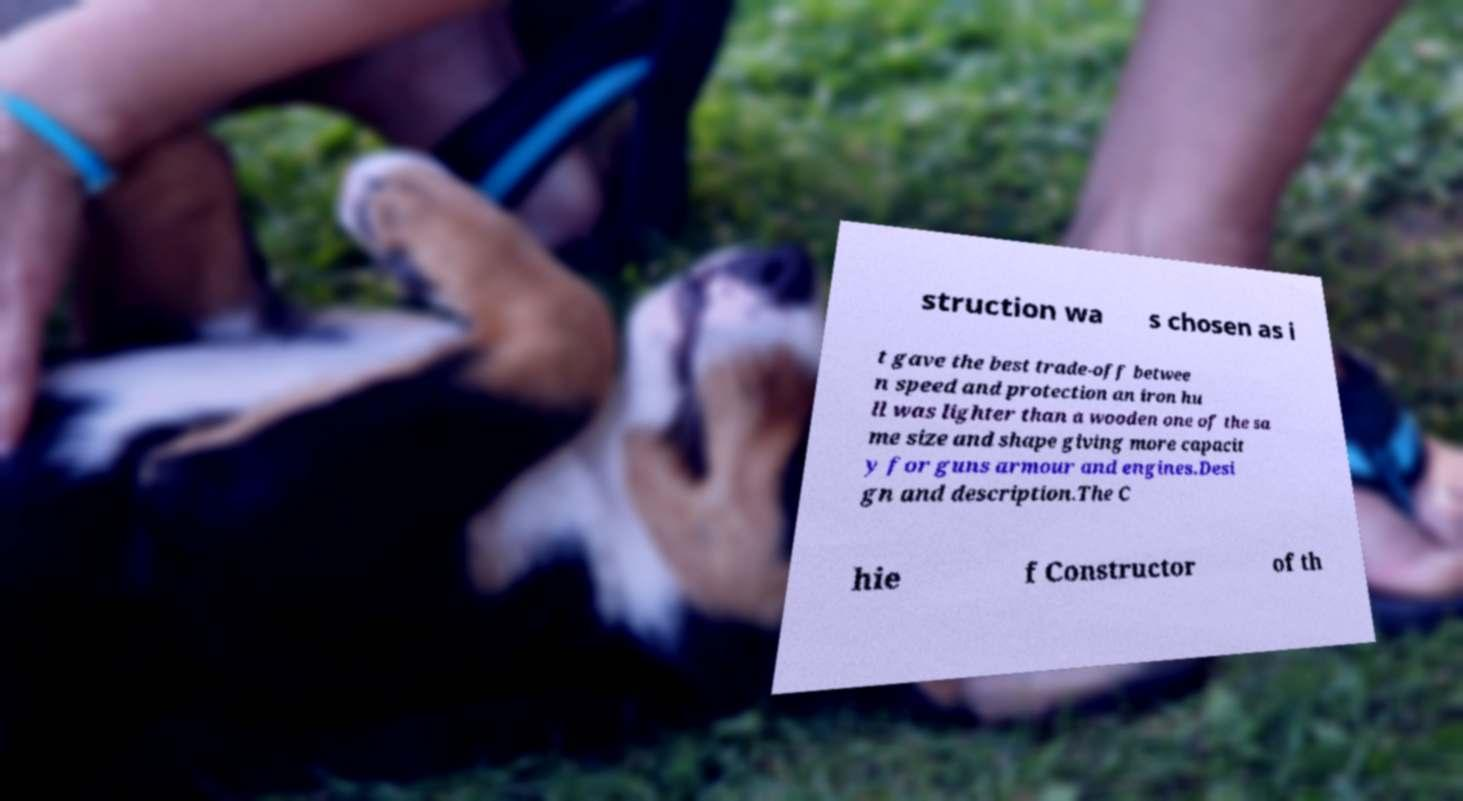Can you read and provide the text displayed in the image?This photo seems to have some interesting text. Can you extract and type it out for me? struction wa s chosen as i t gave the best trade-off betwee n speed and protection an iron hu ll was lighter than a wooden one of the sa me size and shape giving more capacit y for guns armour and engines.Desi gn and description.The C hie f Constructor of th 